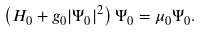Convert formula to latex. <formula><loc_0><loc_0><loc_500><loc_500>\left ( H _ { 0 } + g _ { 0 } | \Psi _ { 0 } | ^ { 2 } \right ) \Psi _ { 0 } = \mu _ { 0 } \Psi _ { 0 } .</formula> 